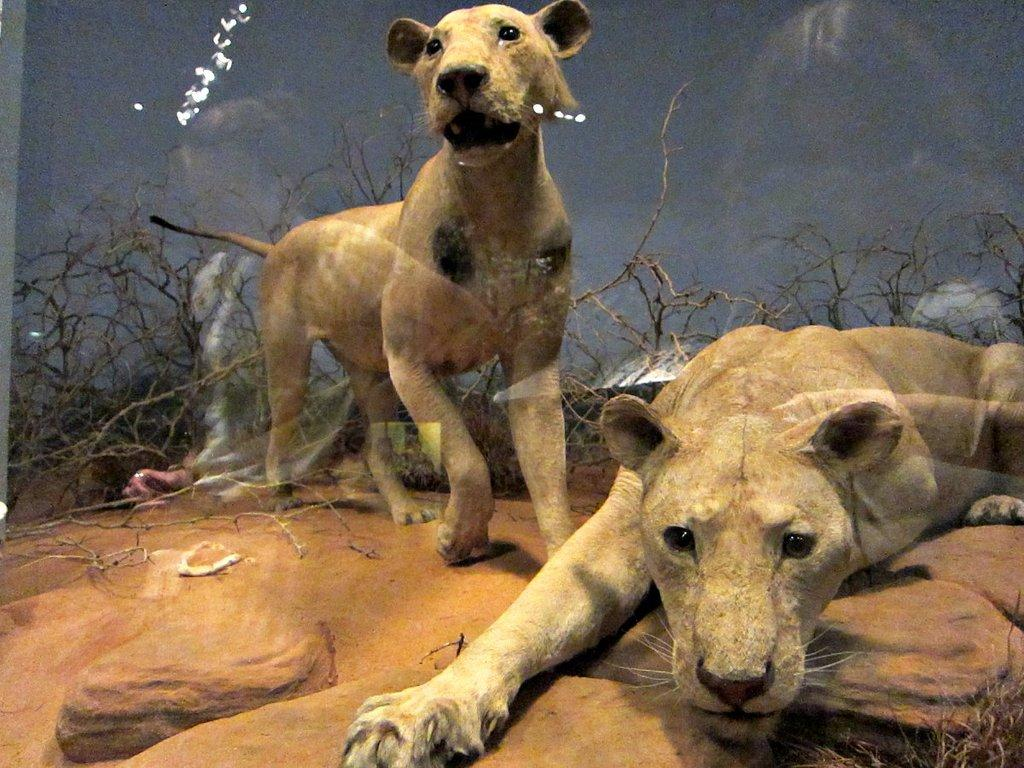What animals are in the center of the image? There are two lions in the center of the image. What type of terrain is at the bottom of the image? There is sand and rocks at the bottom of the image. What can be seen in the background of the image? There are plants and the sky visible in the background of the image. What type of key is used to unlock the design of the lions in the image? There is no key or design present in the image; it features two lions in a natural setting. 